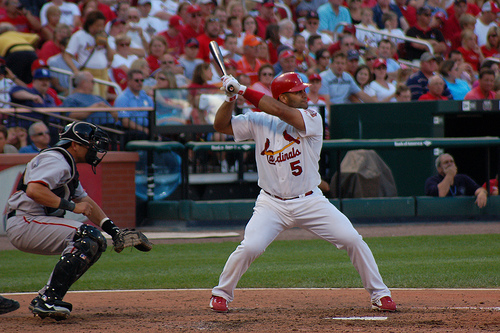What do you think the outcome of this swing might be? It's impossible to predict the outcome of this swing with absolute certainty from a still image. However, the batter's form and focus suggest he's aiming for a strong hit. Outcomes could range from hitting a home run to making solid contact for a base hit or missing the ball entirely. 